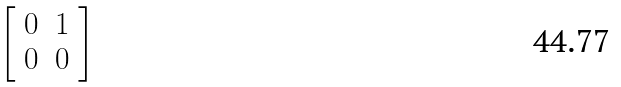<formula> <loc_0><loc_0><loc_500><loc_500>\left [ \begin{array} { l l } { 0 } & { 1 } \\ { 0 } & { 0 } \end{array} \right ]</formula> 